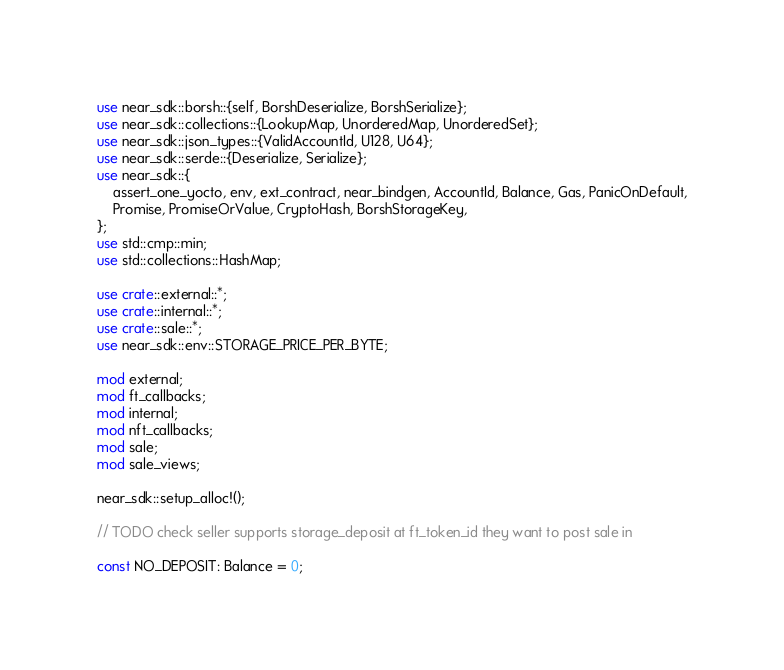Convert code to text. <code><loc_0><loc_0><loc_500><loc_500><_Rust_>use near_sdk::borsh::{self, BorshDeserialize, BorshSerialize};
use near_sdk::collections::{LookupMap, UnorderedMap, UnorderedSet};
use near_sdk::json_types::{ValidAccountId, U128, U64};
use near_sdk::serde::{Deserialize, Serialize};
use near_sdk::{
    assert_one_yocto, env, ext_contract, near_bindgen, AccountId, Balance, Gas, PanicOnDefault,
    Promise, PromiseOrValue, CryptoHash, BorshStorageKey,
};
use std::cmp::min;
use std::collections::HashMap;

use crate::external::*;
use crate::internal::*;
use crate::sale::*;
use near_sdk::env::STORAGE_PRICE_PER_BYTE;

mod external;
mod ft_callbacks;
mod internal;
mod nft_callbacks;
mod sale;
mod sale_views;

near_sdk::setup_alloc!();

// TODO check seller supports storage_deposit at ft_token_id they want to post sale in

const NO_DEPOSIT: Balance = 0;</code> 